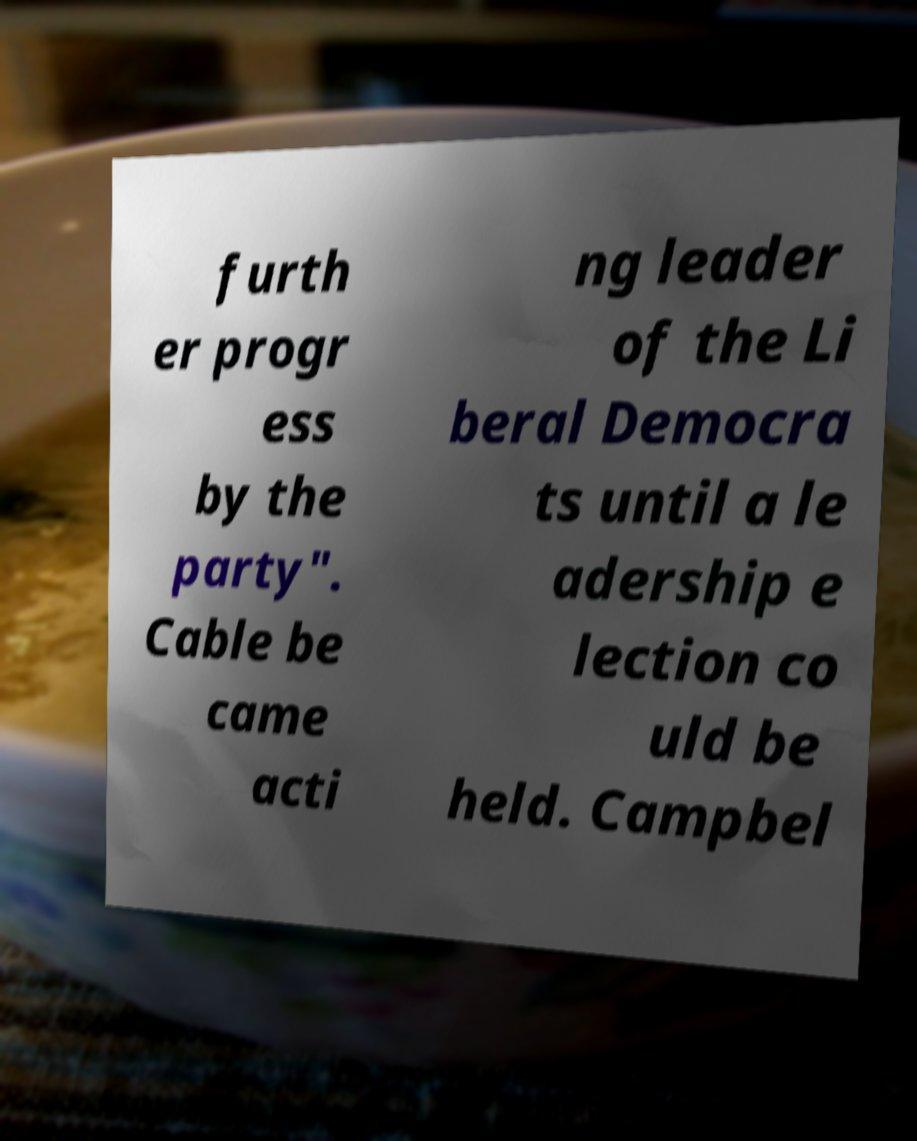For documentation purposes, I need the text within this image transcribed. Could you provide that? furth er progr ess by the party". Cable be came acti ng leader of the Li beral Democra ts until a le adership e lection co uld be held. Campbel 